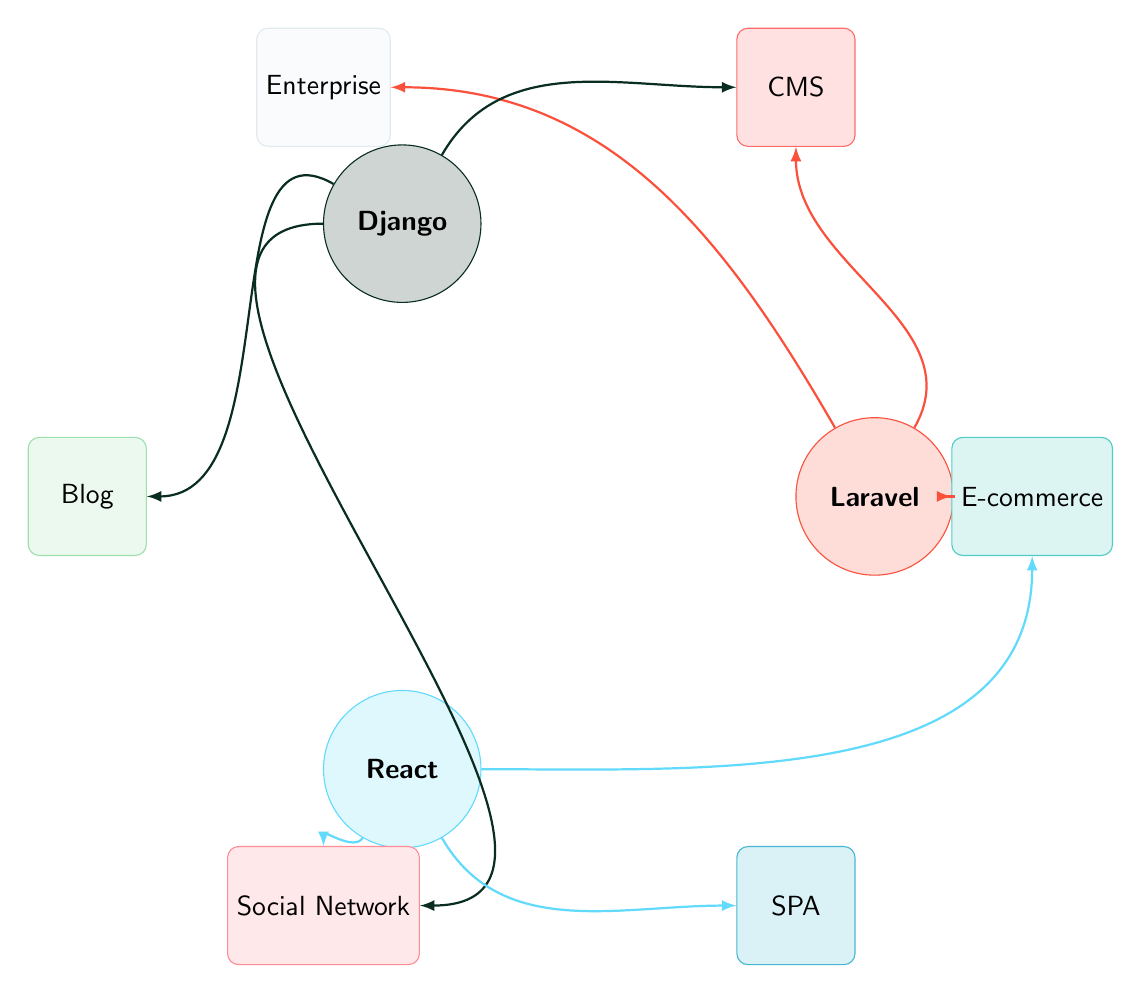What frameworks are recommended for creating a Blog? From the diagram, we see that the framework "Django" has a direct link to the node "Blog." This indicates that Django is suitable for building blog websites.
Answer: Django How many nodes are there in total? By counting all unique nodes displayed in the diagram, we find there are 8 nodes: 3 frameworks (Laravel, Django, React) and 5 project types (Content Management System, E-commerce Platform, Single Page Application, Social Network, Blog, Enterprise Application).
Answer: 8 Which framework is linked to the Enterprise Application? The diagram shows that "Laravel" has a direct connection to the "Enterprise Application" node. This shows that Laravel is best suited for enterprise-level applications.
Answer: Laravel Does React have any association with Content Management System? In the diagram, there is no link between "React" and "Content Management System." This means React is not typically recommended for Content Management Systems.
Answer: No How many links are associated with the Django framework? By examining the connections from the "Django" node to other nodes, we can see 3 links: one to "Content Management System," one to "Social Network," and one to "Blog." Thus, there are three connections for Django.
Answer: 3 Which project type is associated with React and Django but not with Laravel? Observing the links, we see that both "Social Network" has connections from React and Django, but not from Laravel. This makes "Social Network" the type linked with both frameworks.
Answer: Social Network What is the most versatile framework in terms of project types linked? By comparing the connections, "React" is linked to 3 project types: "Single Page Application," "E-commerce Platform," and "Social Network." Since this is the most set of links, React is the most versatile framework shown.
Answer: React 